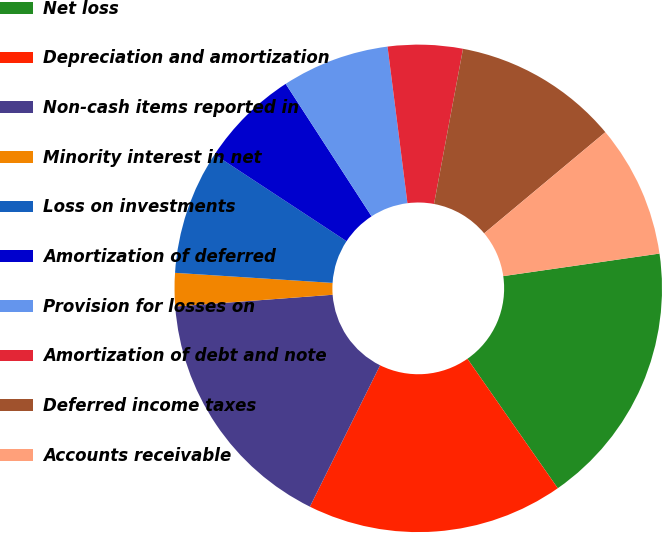<chart> <loc_0><loc_0><loc_500><loc_500><pie_chart><fcel>Net loss<fcel>Depreciation and amortization<fcel>Non-cash items reported in<fcel>Minority interest in net<fcel>Loss on investments<fcel>Amortization of deferred<fcel>Provision for losses on<fcel>Amortization of debt and note<fcel>Deferred income taxes<fcel>Accounts receivable<nl><fcel>17.58%<fcel>17.03%<fcel>16.48%<fcel>2.2%<fcel>8.24%<fcel>6.59%<fcel>7.14%<fcel>4.95%<fcel>10.99%<fcel>8.79%<nl></chart> 